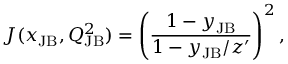<formula> <loc_0><loc_0><loc_500><loc_500>J ( x _ { J B } , Q _ { J B } ^ { 2 } ) = \left ( \frac { 1 - y _ { J B } } { 1 - y _ { J B } / z ^ { \prime } } \right ) ^ { 2 } ,</formula> 